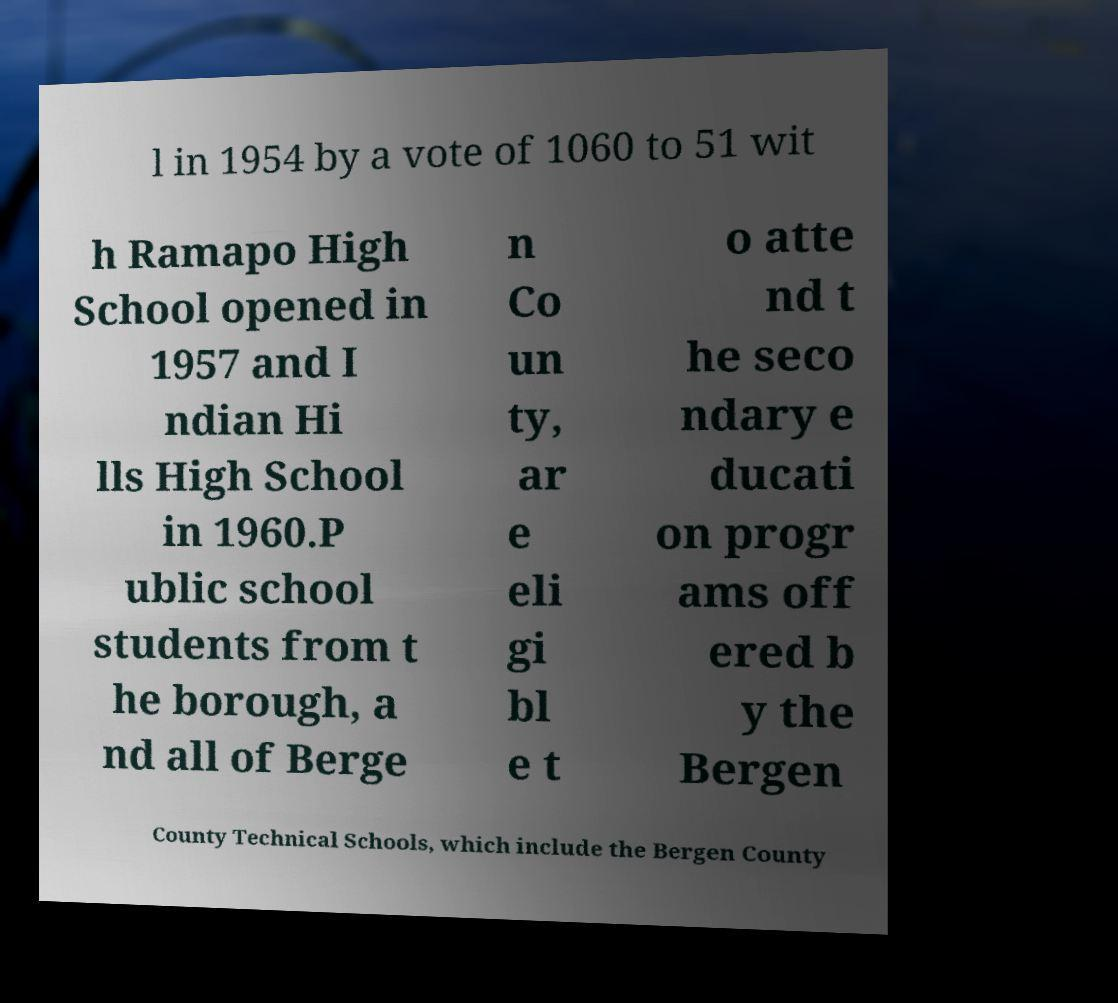What messages or text are displayed in this image? I need them in a readable, typed format. l in 1954 by a vote of 1060 to 51 wit h Ramapo High School opened in 1957 and I ndian Hi lls High School in 1960.P ublic school students from t he borough, a nd all of Berge n Co un ty, ar e eli gi bl e t o atte nd t he seco ndary e ducati on progr ams off ered b y the Bergen County Technical Schools, which include the Bergen County 